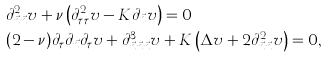Convert formula to latex. <formula><loc_0><loc_0><loc_500><loc_500>& \partial ^ { 2 } _ { \vec { n } \vec { n } } v + \nu \left ( \partial ^ { 2 } _ { \tau \tau } v - K \partial _ { \vec { n } } v \right ) = 0 \\ & ( 2 - \nu ) \partial _ { \tau } \partial _ { \vec { n } } \partial _ { \tau } v + \partial ^ { 3 } _ { \vec { n } \vec { n } \vec { n } } v + K \left ( \Delta v + 2 \partial ^ { 2 } _ { \vec { n } \vec { n } } v \right ) = 0 ,</formula> 